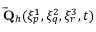Convert formula to latex. <formula><loc_0><loc_0><loc_500><loc_500>\bar { Q } _ { h } ( \xi _ { p } ^ { 1 } , \xi _ { q } ^ { 2 } , \xi _ { r } ^ { 3 } , t )</formula> 